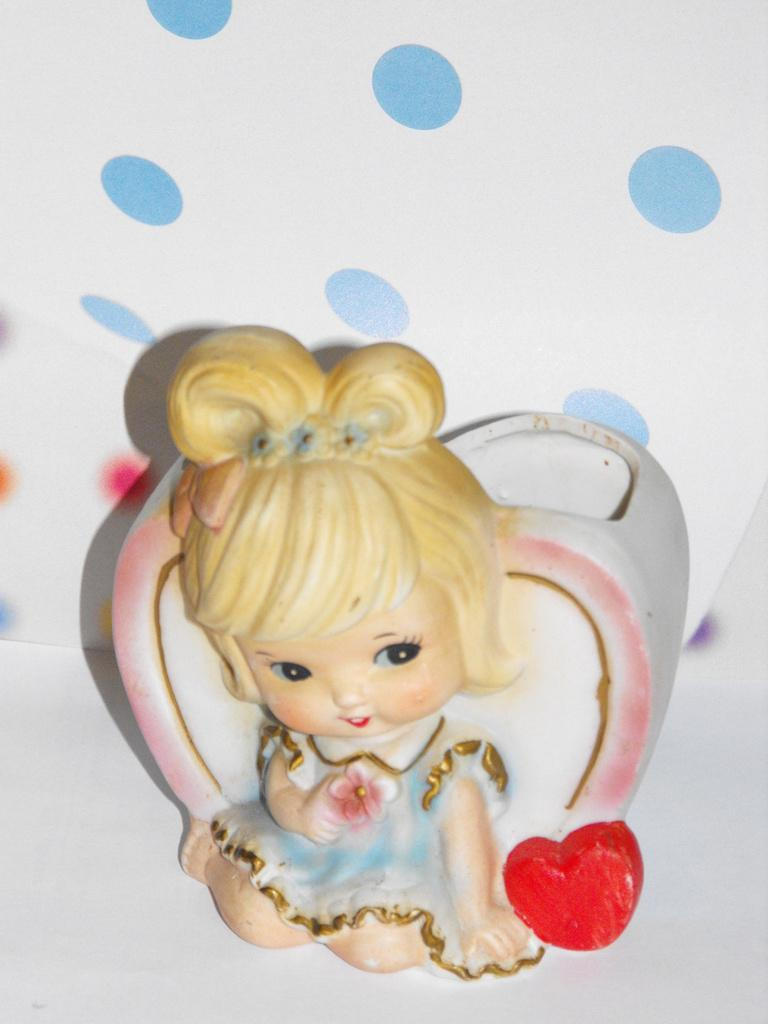What object can be seen in the image? There is a toy in the image. On what surface is the toy placed? The toy is placed on a white surface. What colors are present in the image? There are blue circles on a white background in the image. What type of gun is visible in the image? There is no gun present in the image. How many buns are stacked on top of each other in the image? There are no buns present in the image. 